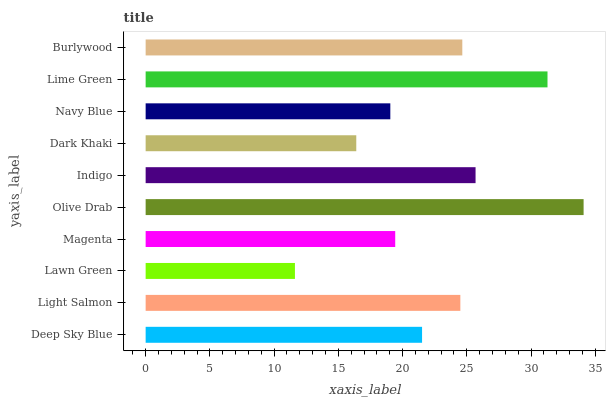Is Lawn Green the minimum?
Answer yes or no. Yes. Is Olive Drab the maximum?
Answer yes or no. Yes. Is Light Salmon the minimum?
Answer yes or no. No. Is Light Salmon the maximum?
Answer yes or no. No. Is Light Salmon greater than Deep Sky Blue?
Answer yes or no. Yes. Is Deep Sky Blue less than Light Salmon?
Answer yes or no. Yes. Is Deep Sky Blue greater than Light Salmon?
Answer yes or no. No. Is Light Salmon less than Deep Sky Blue?
Answer yes or no. No. Is Light Salmon the high median?
Answer yes or no. Yes. Is Deep Sky Blue the low median?
Answer yes or no. Yes. Is Dark Khaki the high median?
Answer yes or no. No. Is Navy Blue the low median?
Answer yes or no. No. 